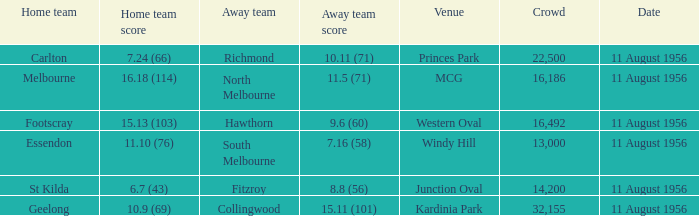What is the home team score for Footscray? 15.13 (103). 